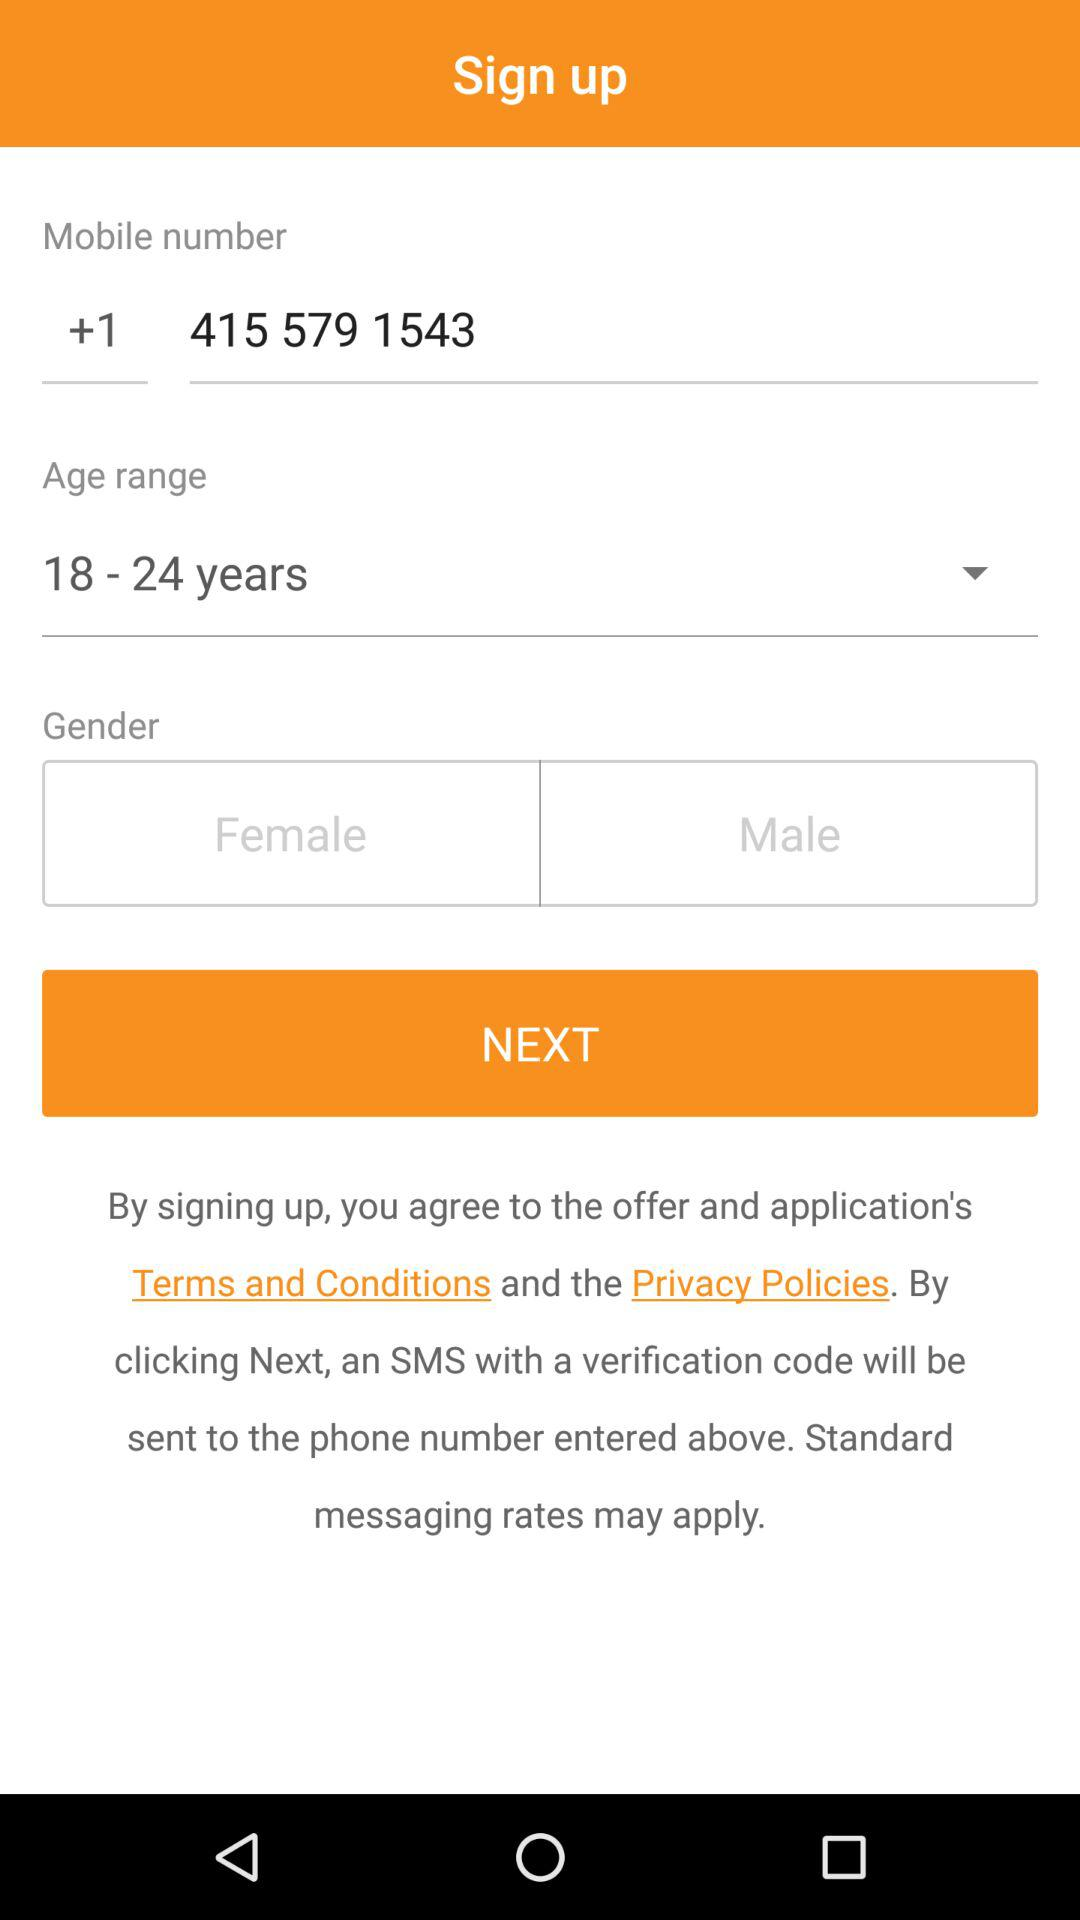Which gender is selected?
When the provided information is insufficient, respond with <no answer>. <no answer> 